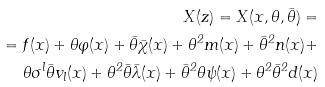Convert formula to latex. <formula><loc_0><loc_0><loc_500><loc_500>X ( z ) = X ( x , \theta , \bar { \theta } ) = \\ = f ( x ) + \theta \varphi ( x ) + \bar { \theta } \bar { \chi } ( x ) + \theta ^ { 2 } m ( x ) + \bar { \theta } ^ { 2 } n ( x ) + \\ \theta \sigma ^ { l } \bar { \theta } v _ { l } ( x ) + \theta ^ { 2 } \bar { \theta } \bar { \lambda } ( x ) + \bar { \theta } ^ { 2 } \theta \psi ( x ) + \theta ^ { 2 } \bar { \theta } ^ { 2 } d ( x )</formula> 